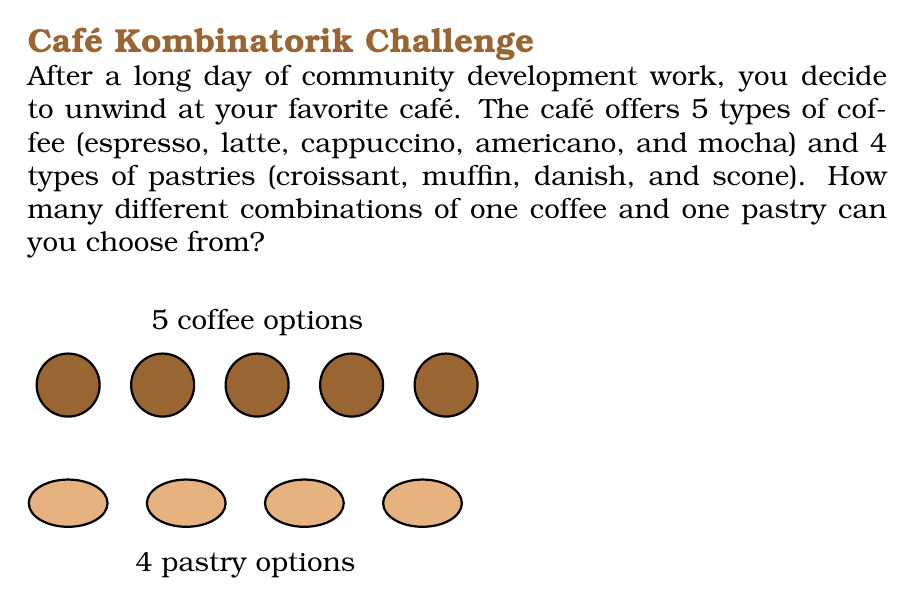Provide a solution to this math problem. To solve this problem, we can use the multiplication principle of counting. The multiplication principle states that if we have $m$ ways of doing one thing and $n$ ways of doing another independent thing, then there are $m \times n$ ways of doing both things.

In this case:
1. We have 5 choices for coffee: espresso, latte, cappuccino, americano, and mocha.
2. We have 4 choices for pastries: croissant, muffin, danish, and scone.
3. We are selecting one coffee and one pastry, and these choices are independent of each other.

Therefore, the total number of possible combinations is:

$$\text{Number of combinations} = \text{Number of coffee choices} \times \text{Number of pastry choices}$$

$$\text{Number of combinations} = 5 \times 4 = 20$$

This means that for each coffee choice, we have 4 pastry options, resulting in 20 different possible combinations of one coffee and one pastry.
Answer: 20 combinations 